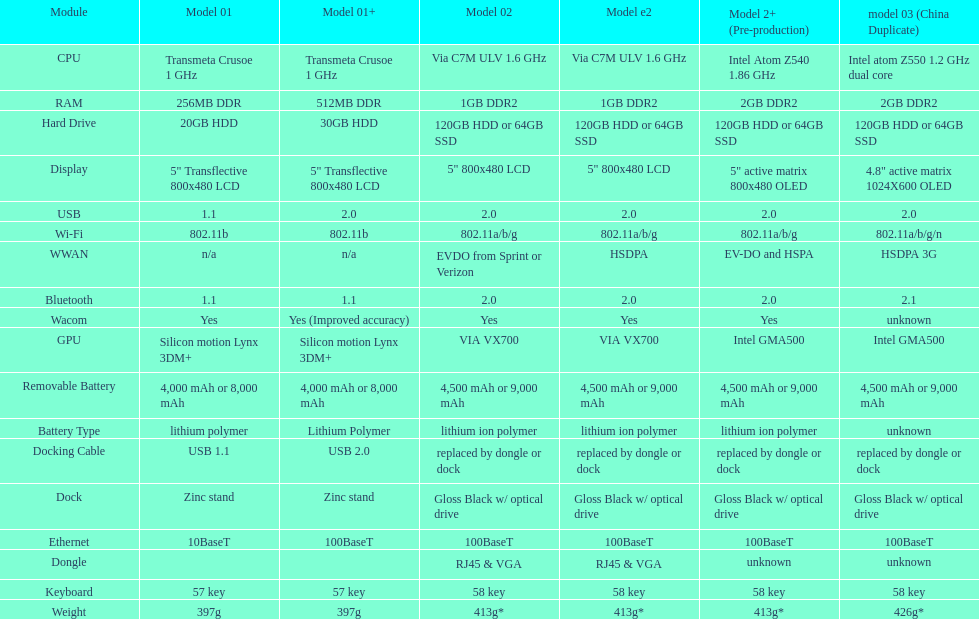What is the next highest hard drive available after the 30gb model? 64GB SSD. 